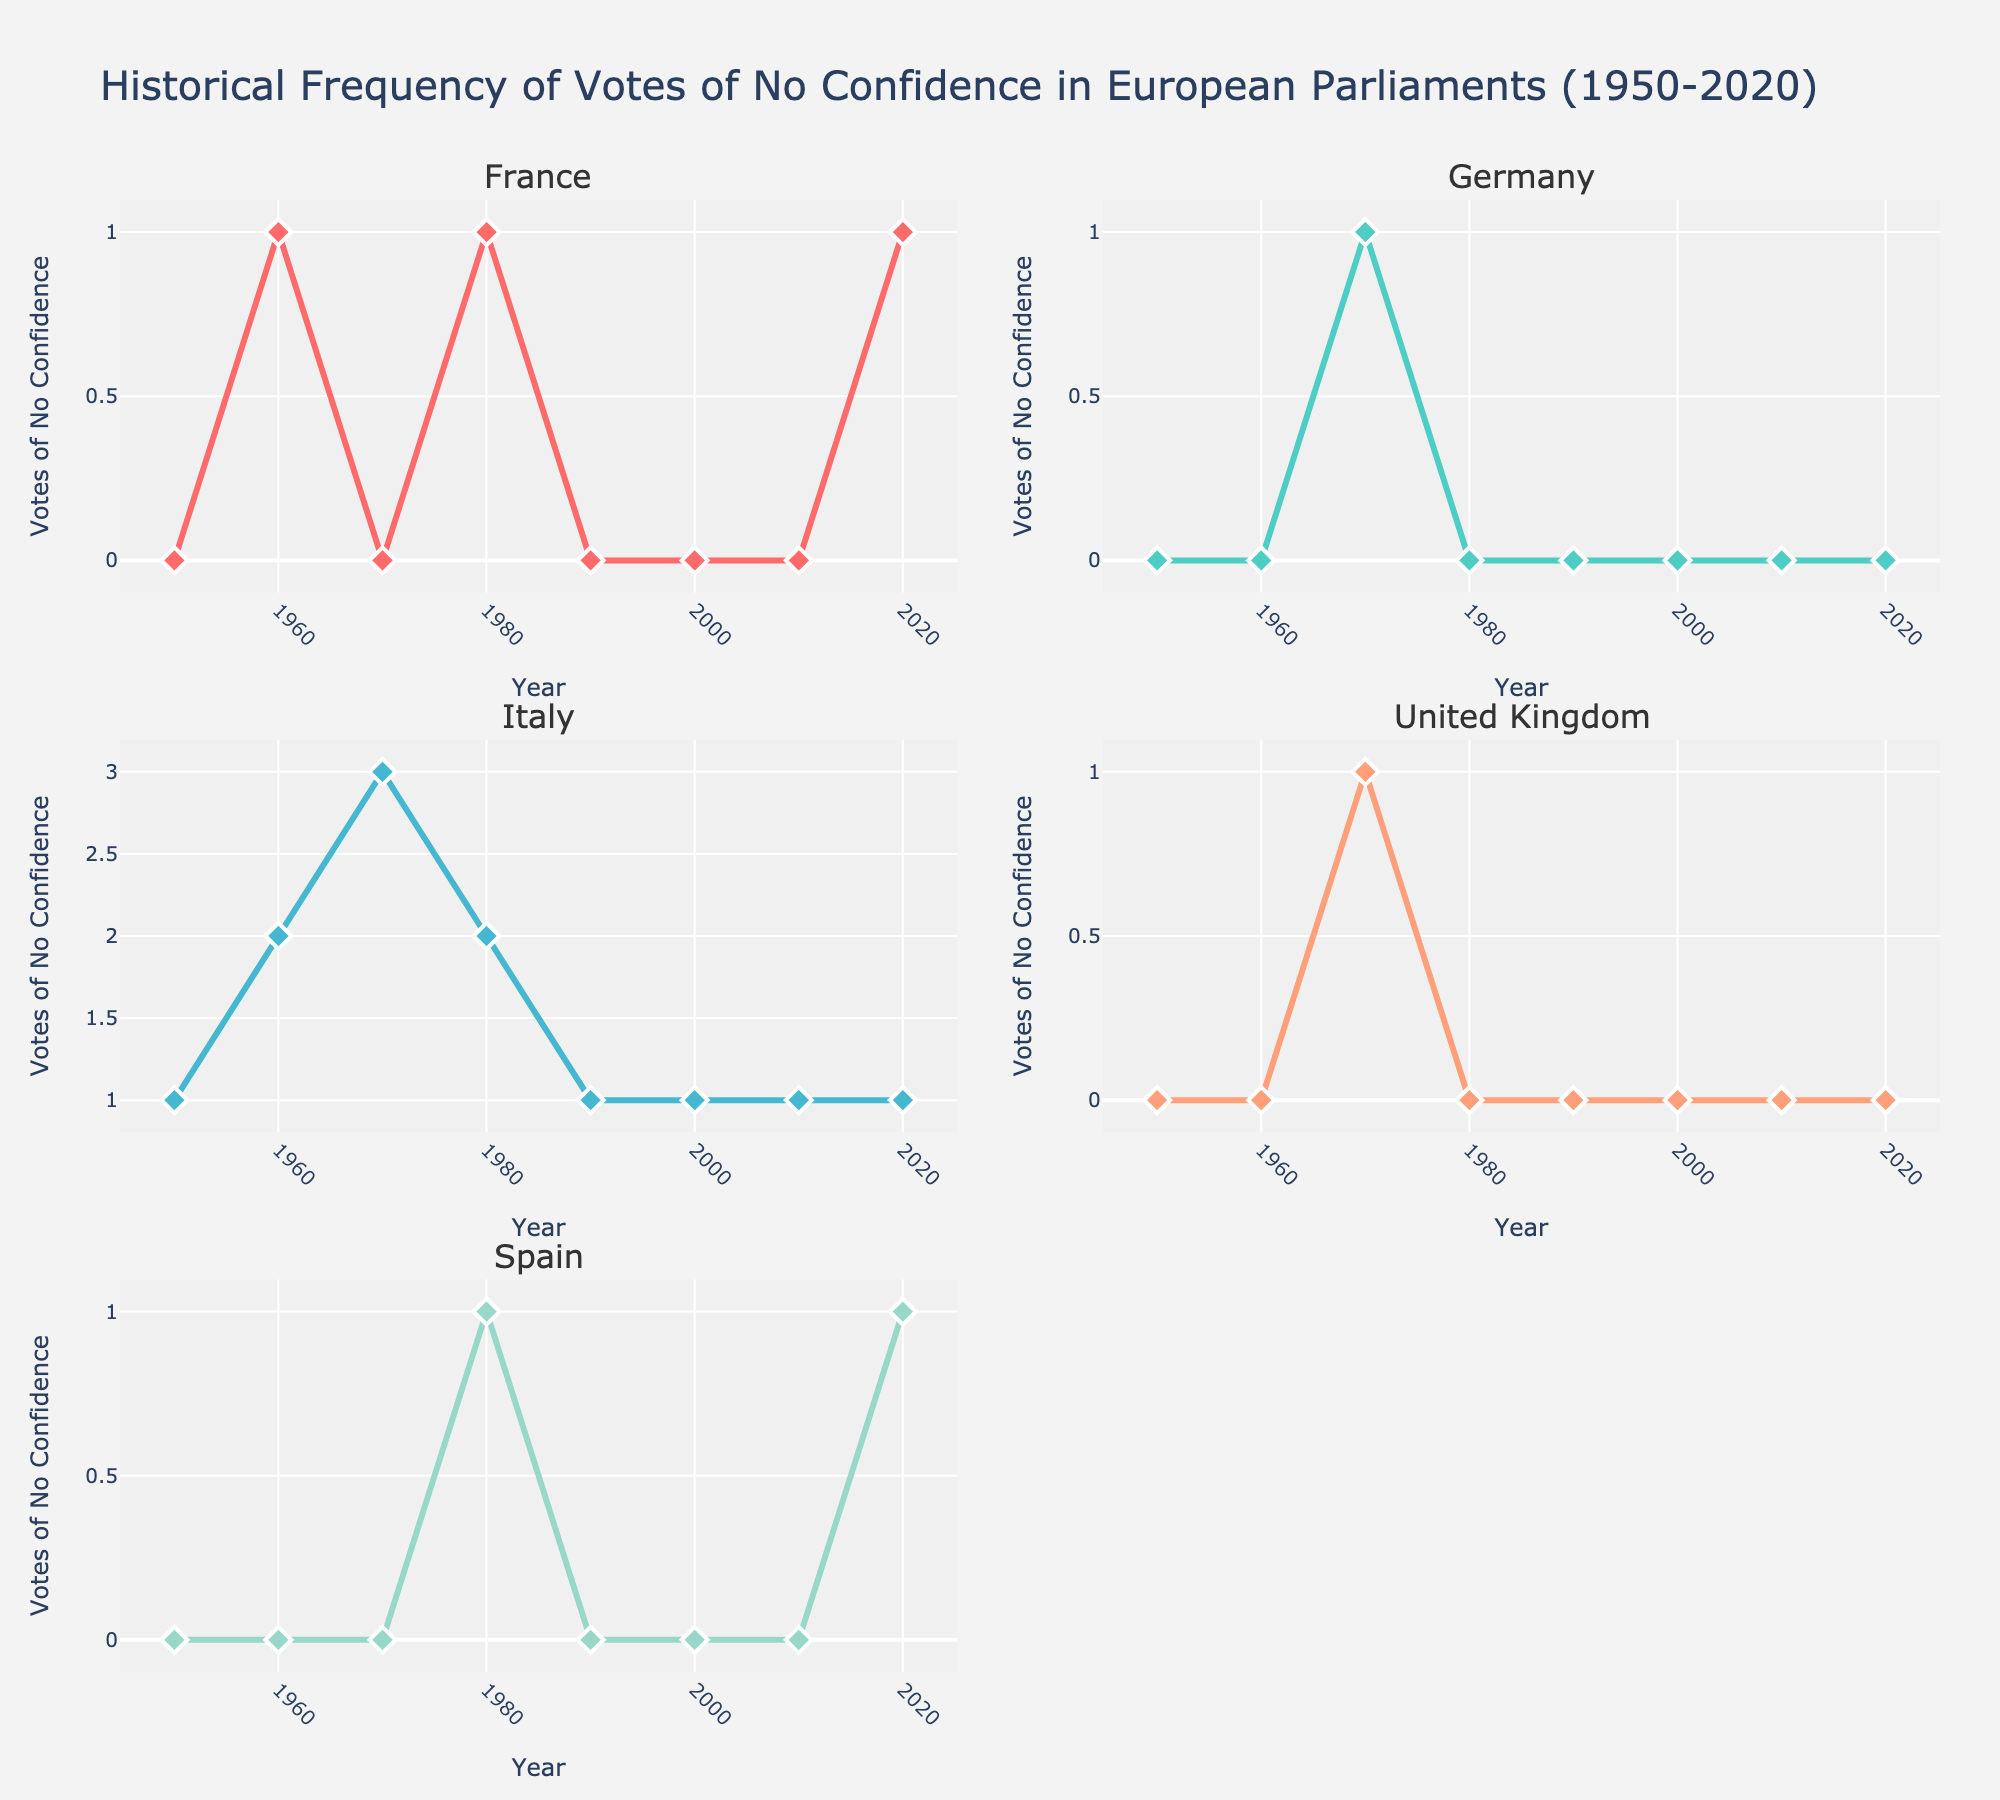Which country's subplot shows the highest number of votes of no confidence in a single year? The plotted data shows the highest number of votes of no confidence in Italy where one of the years (1970) has 3 votes.
Answer: Italy In which years did France experience votes of no confidence? By observing the subplot for France, votes of no confidence occurred in 1960, 1980, and 2020.
Answer: 1960, 1980, 2020 How many votes of no confidence were recorded in Germany in the 1970s? Checking the subplot for Germany, the only year with a vote of no confidence in the 1970s is 1970, and it shows 1 vote.
Answer: 1 Which countries had no votes of no confidence during the decade of the 2000s? Looking at the plots, all countries except Italy show 0 votes of no confidence during the decade of the 2000s.
Answer: France, Germany, United Kingdom, Spain Compare the number of votes of no confidence in Italy and Spain during the 1980s. Italy had 2 votes of no confidence in the 1980s according to its subplot, while Spain had 1 vote in the same period.
Answer: Italy: 2, Spain: 1 Did the United Kingdom have more votes of no confidence in the 1970s than any other decade? According to the United Kingdom's subplot, 1970s had 1 vote of no confidence, while all other decades show 0 votes.
Answer: Yes Calculate the total number of votes of no confidence in France over the entire period shown in the plot. Summing up the years with votes of no confidence in France (1+1+1) equals 3.
Answer: 3 Which two countries have the most different patterns of votes of no confidence over time? Comparing subplots, Italy has frequent votes (multiple years) while Germany shows very infrequent votes (only one instance).
Answer: Italy and Germany In which decade did Italy experience the highest number of votes of no confidence overall? Analyzing the subplot for Italy, the decade of the 1970s had the highest number of votes of no confidence (3 votes).
Answer: 1970s 